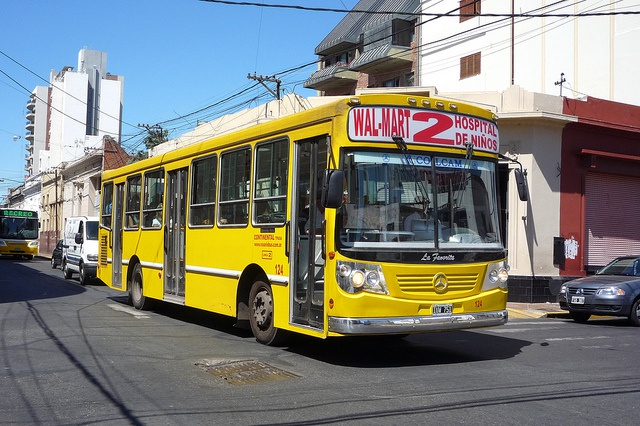Describe the objects in this image and their specific colors. I can see bus in lightblue, black, gray, and gold tones, car in lightblue, black, gray, navy, and darkgray tones, truck in lightblue, white, black, gray, and darkgray tones, bus in lightblue, black, gray, and maroon tones, and people in lightblue, gray, and black tones in this image. 